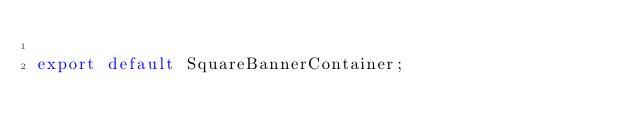Convert code to text. <code><loc_0><loc_0><loc_500><loc_500><_TypeScript_>
export default SquareBannerContainer;
</code> 